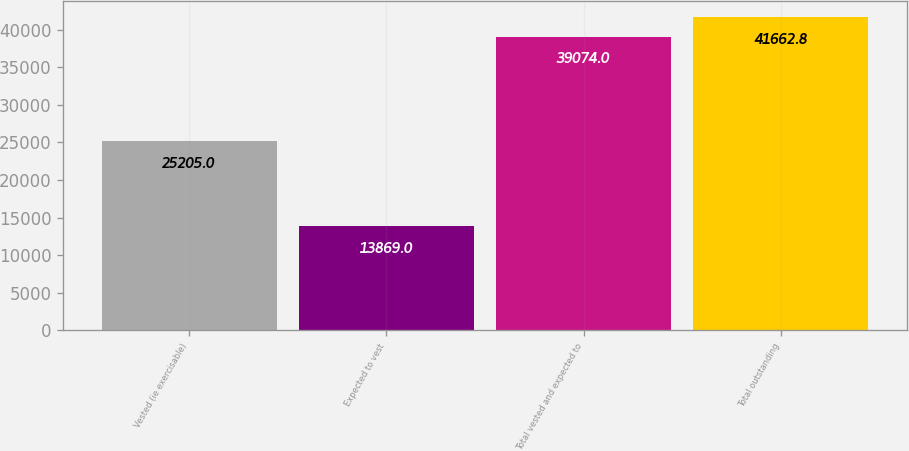Convert chart. <chart><loc_0><loc_0><loc_500><loc_500><bar_chart><fcel>Vested (ie exercisable)<fcel>Expected to vest<fcel>Total vested and expected to<fcel>Total outstanding<nl><fcel>25205<fcel>13869<fcel>39074<fcel>41662.8<nl></chart> 